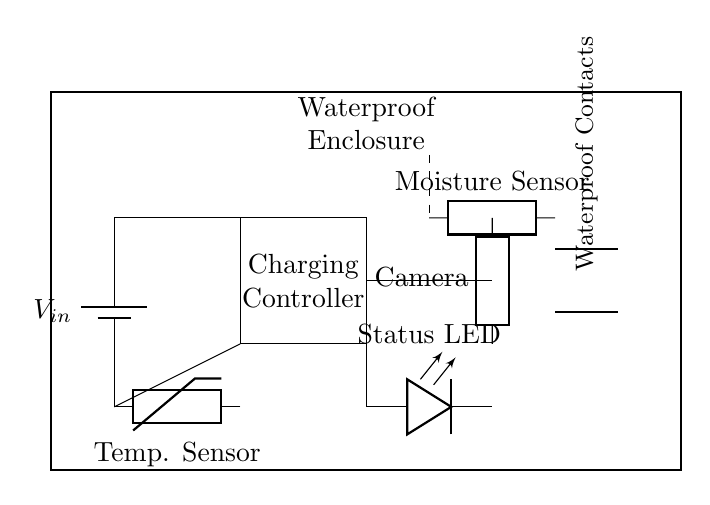What is the power source used in the circuit? The power source is a battery, as indicated by the symbol and label for voltage input.
Answer: Battery What component is used to indicate the charging status? The charging status is indicated by an LED, which is labeled as "Status LED" in the diagram.
Answer: Status LED What is the purpose of the charging controller? The charging controller regulates the flow of power from the battery to the camera, ensuring safe and efficient charging.
Answer: Regulate charging Where are the waterproof contacts located? The waterproof contacts are shown on the right side of the enclosure, labeled specifically in the diagram.
Answer: Right side What type of sensor is included in the circuit? The circuit includes a temperature sensor and a moisture sensor, both vital for monitoring conditions during charging.
Answer: Temperature and moisture sensors How does the circuit prevent moisture damage to the charging components? Moisture damage is prevented by the waterproof enclosure that encapsulates all components, including the connections and sensors.
Answer: Waterproof enclosure Which component connects to the camera? The generic component labeled "Camera" directly connects to the output of the charging controller.
Answer: Generic 